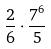<formula> <loc_0><loc_0><loc_500><loc_500>\frac { 2 } { 6 } \cdot \frac { 7 ^ { 6 } } { 5 }</formula> 